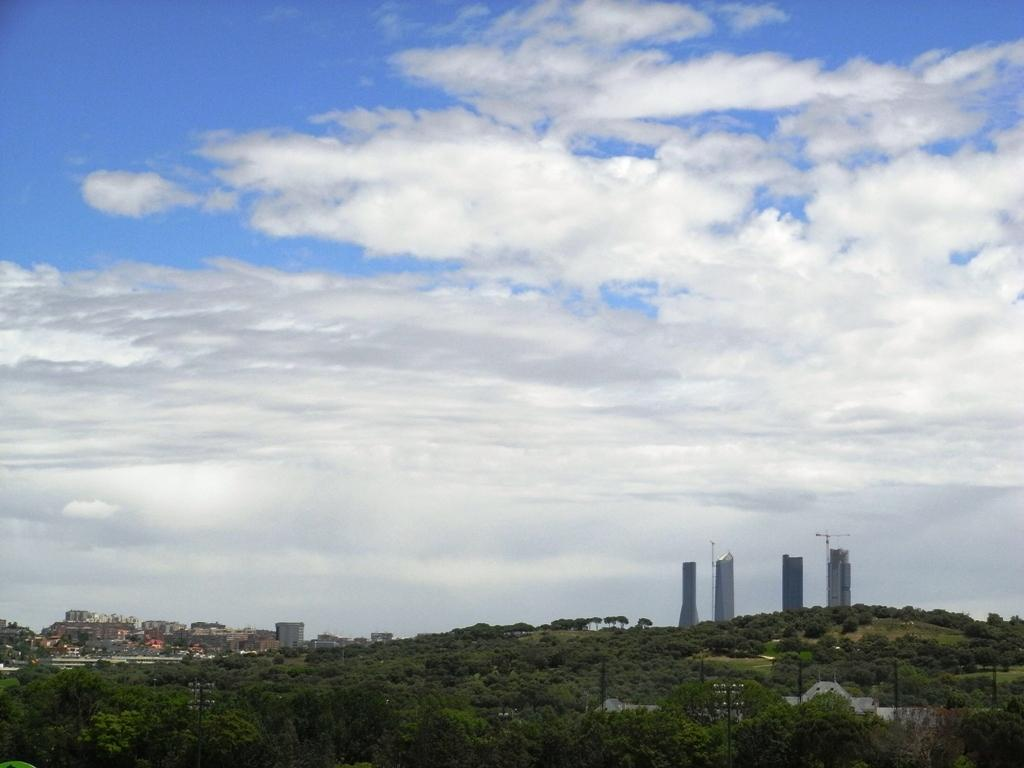What is located in the foreground of the image? There is a group of trees, poles, buildings, and cranes in the foreground of the image. What can be seen in the background of the image? The sky is visible in the background of the image. What is the condition of the sky in the image? The sky appears to be cloudy in the image. Can you tell me how many firemen are standing near the wheel in the image? There is no fireman or wheel present in the image. What is the level of interest in the image? The level of interest in the image cannot be determined, as it is a subjective matter. 